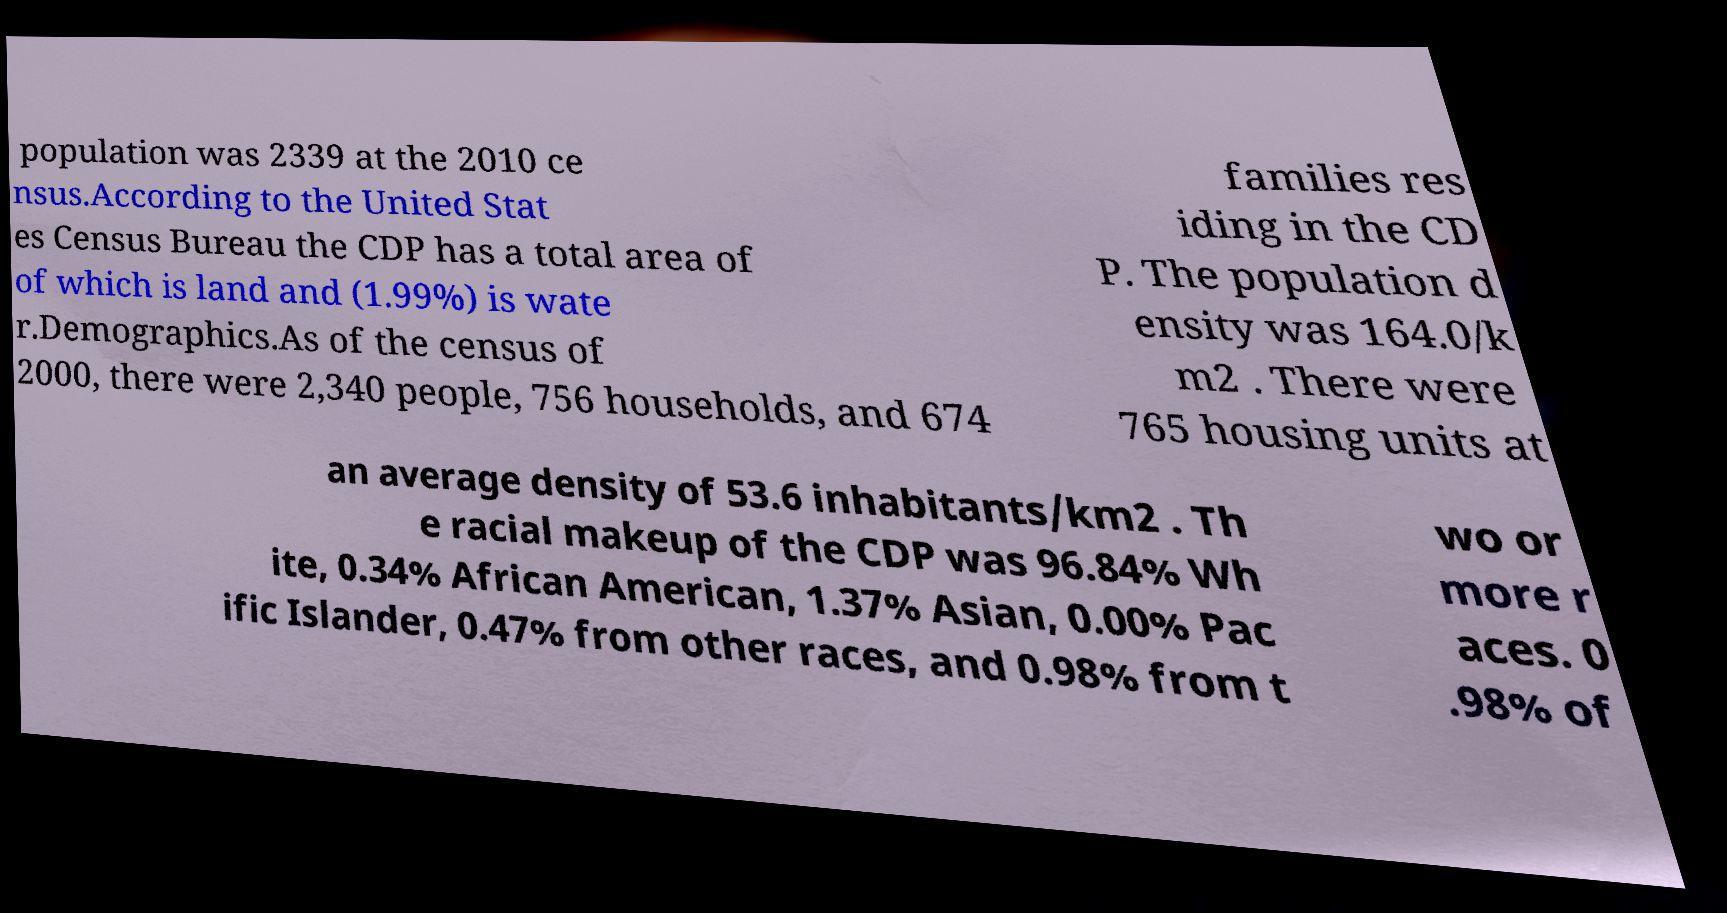Please read and relay the text visible in this image. What does it say? population was 2339 at the 2010 ce nsus.According to the United Stat es Census Bureau the CDP has a total area of of which is land and (1.99%) is wate r.Demographics.As of the census of 2000, there were 2,340 people, 756 households, and 674 families res iding in the CD P. The population d ensity was 164.0/k m2 . There were 765 housing units at an average density of 53.6 inhabitants/km2 . Th e racial makeup of the CDP was 96.84% Wh ite, 0.34% African American, 1.37% Asian, 0.00% Pac ific Islander, 0.47% from other races, and 0.98% from t wo or more r aces. 0 .98% of 